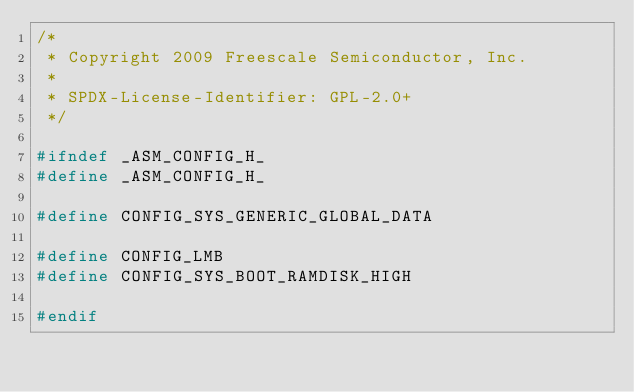Convert code to text. <code><loc_0><loc_0><loc_500><loc_500><_C_>/*
 * Copyright 2009 Freescale Semiconductor, Inc.
 *
 * SPDX-License-Identifier:	GPL-2.0+
 */

#ifndef _ASM_CONFIG_H_
#define _ASM_CONFIG_H_

#define CONFIG_SYS_GENERIC_GLOBAL_DATA

#define CONFIG_LMB
#define CONFIG_SYS_BOOT_RAMDISK_HIGH

#endif
</code> 